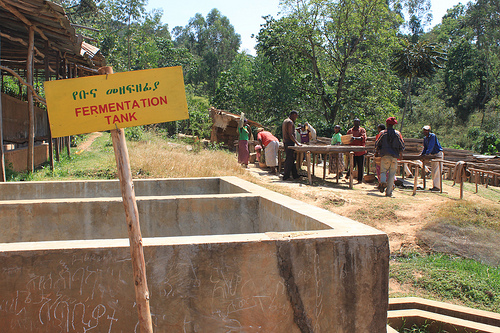<image>
Is there a tree behind the sign? Yes. From this viewpoint, the tree is positioned behind the sign, with the sign partially or fully occluding the tree. 